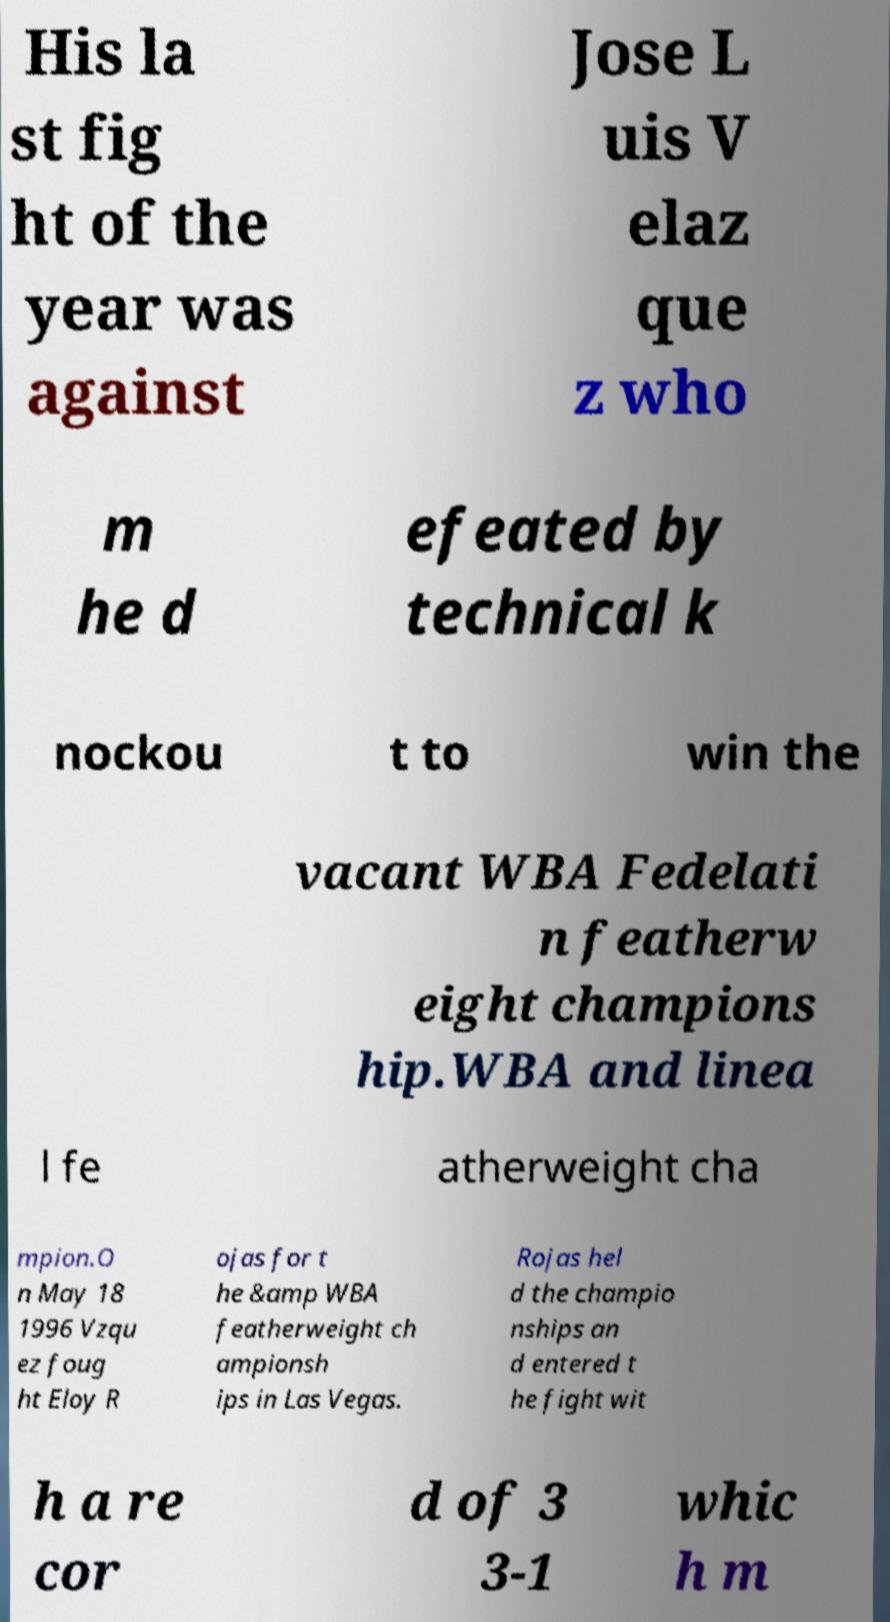Can you read and provide the text displayed in the image?This photo seems to have some interesting text. Can you extract and type it out for me? His la st fig ht of the year was against Jose L uis V elaz que z who m he d efeated by technical k nockou t to win the vacant WBA Fedelati n featherw eight champions hip.WBA and linea l fe atherweight cha mpion.O n May 18 1996 Vzqu ez foug ht Eloy R ojas for t he &amp WBA featherweight ch ampionsh ips in Las Vegas. Rojas hel d the champio nships an d entered t he fight wit h a re cor d of 3 3-1 whic h m 